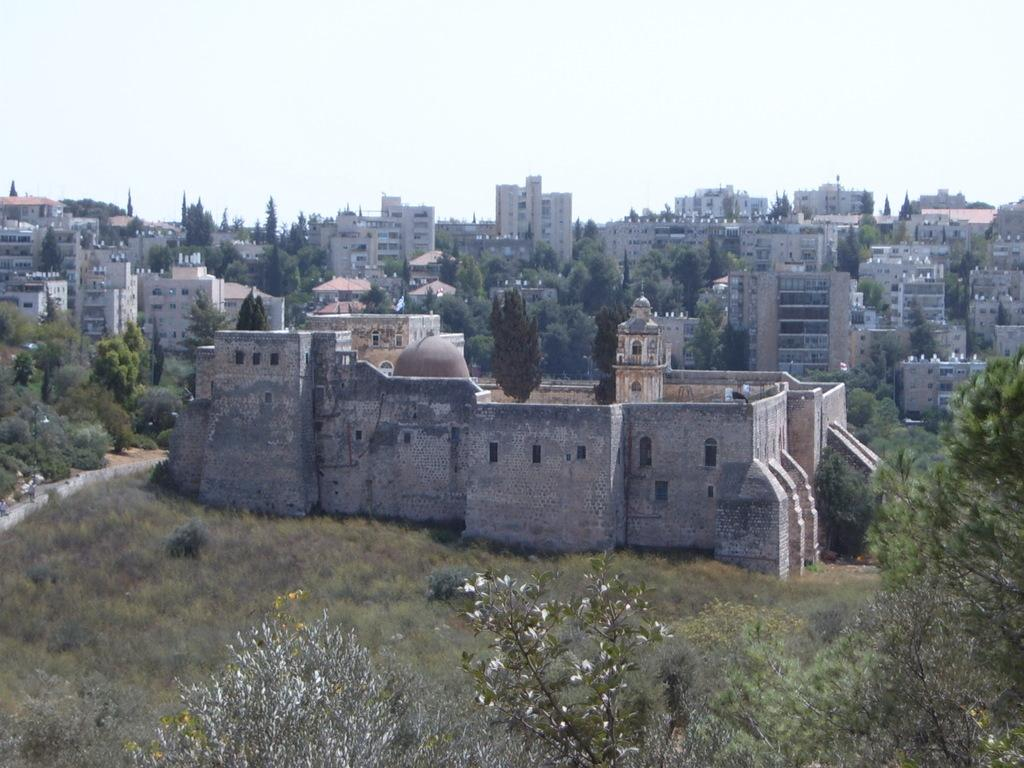What can be seen in the background of the image? The sky is visible in the image. What type of structures are present in the image? There are buildings in the image. What architectural feature can be seen on the buildings? Windows are present in the image. What type of vegetation is visible in the image? Trees are in the image. Can you describe any other objects in the image? There are a few other objects in the image. What verse is being recited by the rake in the image? There is no rake or verse present in the image. 